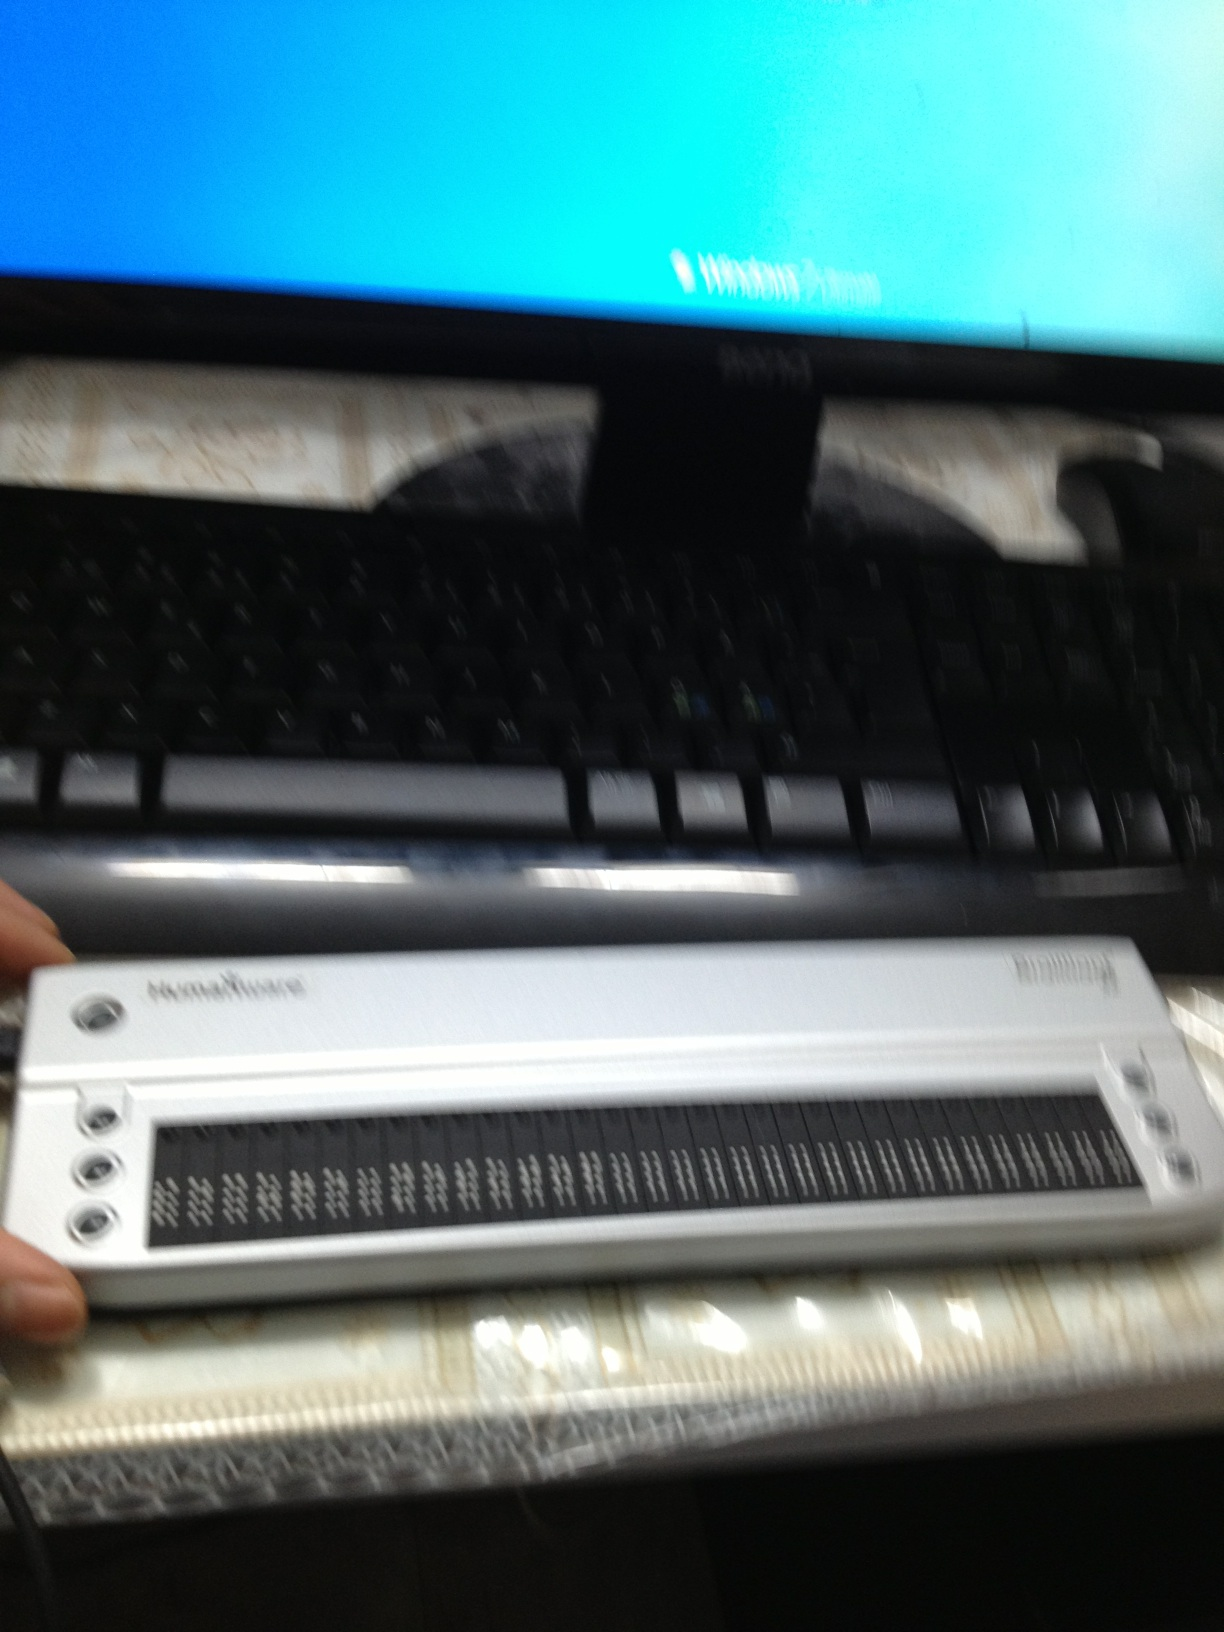What kind of I see a blurry image that appears to depict a computing device setup with a monitor displaying a blurred Windows login screen, a keyboard, and a refreshable braille display. Could you provide more details or clarify your question? 